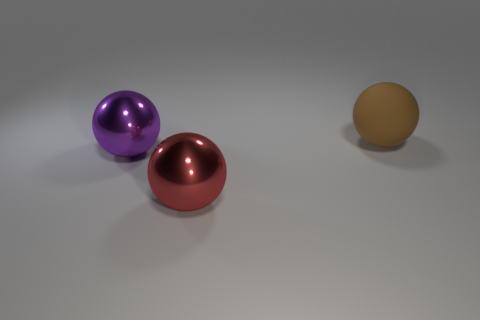Are there more purple things to the right of the big red metallic thing than big balls?
Provide a short and direct response. No. Are there any big matte objects of the same color as the rubber ball?
Give a very brief answer. No. There is a rubber object that is the same size as the red sphere; what color is it?
Your answer should be compact. Brown. There is a large thing to the left of the red metallic ball; what number of red metallic things are right of it?
Your answer should be very brief. 1. How many things are either big spheres in front of the rubber thing or red spheres?
Your answer should be very brief. 2. What number of large red spheres are made of the same material as the red thing?
Provide a short and direct response. 0. Are there an equal number of big purple metallic objects to the right of the rubber thing and big red metallic things?
Your answer should be very brief. No. What size is the object that is to the right of the red metal sphere?
Your answer should be compact. Large. How many large things are either green metal objects or metallic spheres?
Your response must be concise. 2. What is the color of the other metallic thing that is the same shape as the big purple shiny thing?
Your answer should be compact. Red. 